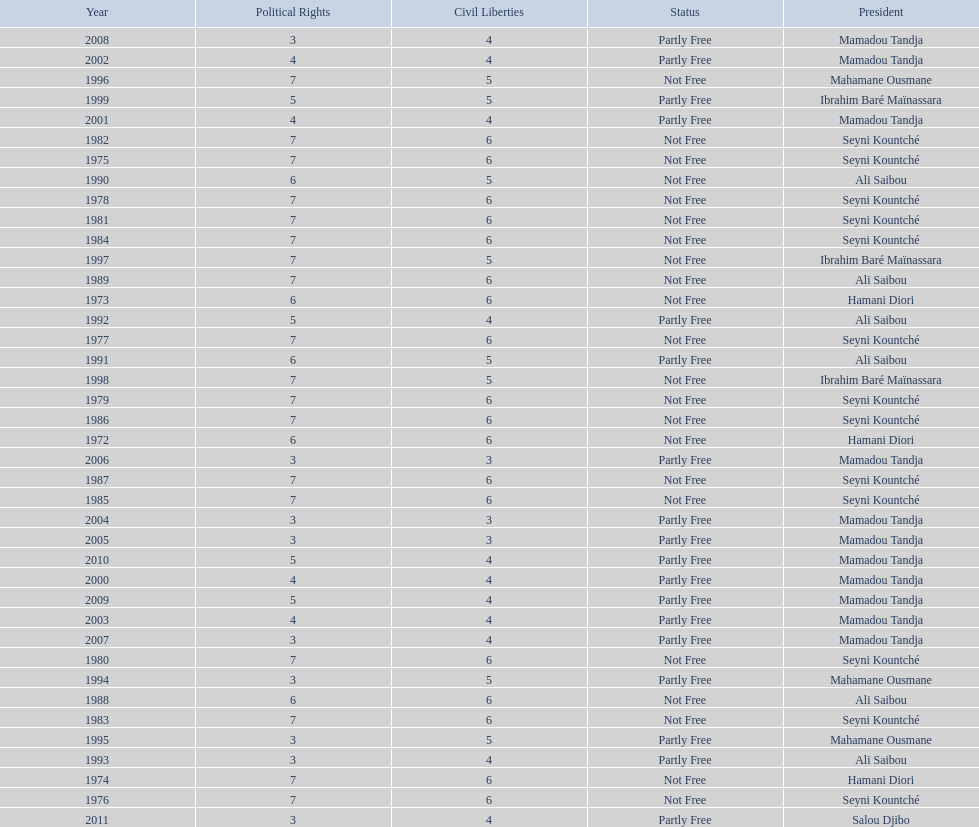How long did it take for civil liberties to decrease below 6? 18 years. I'm looking to parse the entire table for insights. Could you assist me with that? {'header': ['Year', 'Political Rights', 'Civil Liberties', 'Status', 'President'], 'rows': [['2008', '3', '4', 'Partly Free', 'Mamadou Tandja'], ['2002', '4', '4', 'Partly Free', 'Mamadou Tandja'], ['1996', '7', '5', 'Not Free', 'Mahamane Ousmane'], ['1999', '5', '5', 'Partly Free', 'Ibrahim Baré Maïnassara'], ['2001', '4', '4', 'Partly Free', 'Mamadou Tandja'], ['1982', '7', '6', 'Not Free', 'Seyni Kountché'], ['1975', '7', '6', 'Not Free', 'Seyni Kountché'], ['1990', '6', '5', 'Not Free', 'Ali Saibou'], ['1978', '7', '6', 'Not Free', 'Seyni Kountché'], ['1981', '7', '6', 'Not Free', 'Seyni Kountché'], ['1984', '7', '6', 'Not Free', 'Seyni Kountché'], ['1997', '7', '5', 'Not Free', 'Ibrahim Baré Maïnassara'], ['1989', '7', '6', 'Not Free', 'Ali Saibou'], ['1973', '6', '6', 'Not Free', 'Hamani Diori'], ['1992', '5', '4', 'Partly Free', 'Ali Saibou'], ['1977', '7', '6', 'Not Free', 'Seyni Kountché'], ['1991', '6', '5', 'Partly Free', 'Ali Saibou'], ['1998', '7', '5', 'Not Free', 'Ibrahim Baré Maïnassara'], ['1979', '7', '6', 'Not Free', 'Seyni Kountché'], ['1986', '7', '6', 'Not Free', 'Seyni Kountché'], ['1972', '6', '6', 'Not Free', 'Hamani Diori'], ['2006', '3', '3', 'Partly Free', 'Mamadou Tandja'], ['1987', '7', '6', 'Not Free', 'Seyni Kountché'], ['1985', '7', '6', 'Not Free', 'Seyni Kountché'], ['2004', '3', '3', 'Partly Free', 'Mamadou Tandja'], ['2005', '3', '3', 'Partly Free', 'Mamadou Tandja'], ['2010', '5', '4', 'Partly Free', 'Mamadou Tandja'], ['2000', '4', '4', 'Partly Free', 'Mamadou Tandja'], ['2009', '5', '4', 'Partly Free', 'Mamadou Tandja'], ['2003', '4', '4', 'Partly Free', 'Mamadou Tandja'], ['2007', '3', '4', 'Partly Free', 'Mamadou Tandja'], ['1980', '7', '6', 'Not Free', 'Seyni Kountché'], ['1994', '3', '5', 'Partly Free', 'Mahamane Ousmane'], ['1988', '6', '6', 'Not Free', 'Ali Saibou'], ['1983', '7', '6', 'Not Free', 'Seyni Kountché'], ['1995', '3', '5', 'Partly Free', 'Mahamane Ousmane'], ['1993', '3', '4', 'Partly Free', 'Ali Saibou'], ['1974', '7', '6', 'Not Free', 'Hamani Diori'], ['1976', '7', '6', 'Not Free', 'Seyni Kountché'], ['2011', '3', '4', 'Partly Free', 'Salou Djibo']]} 